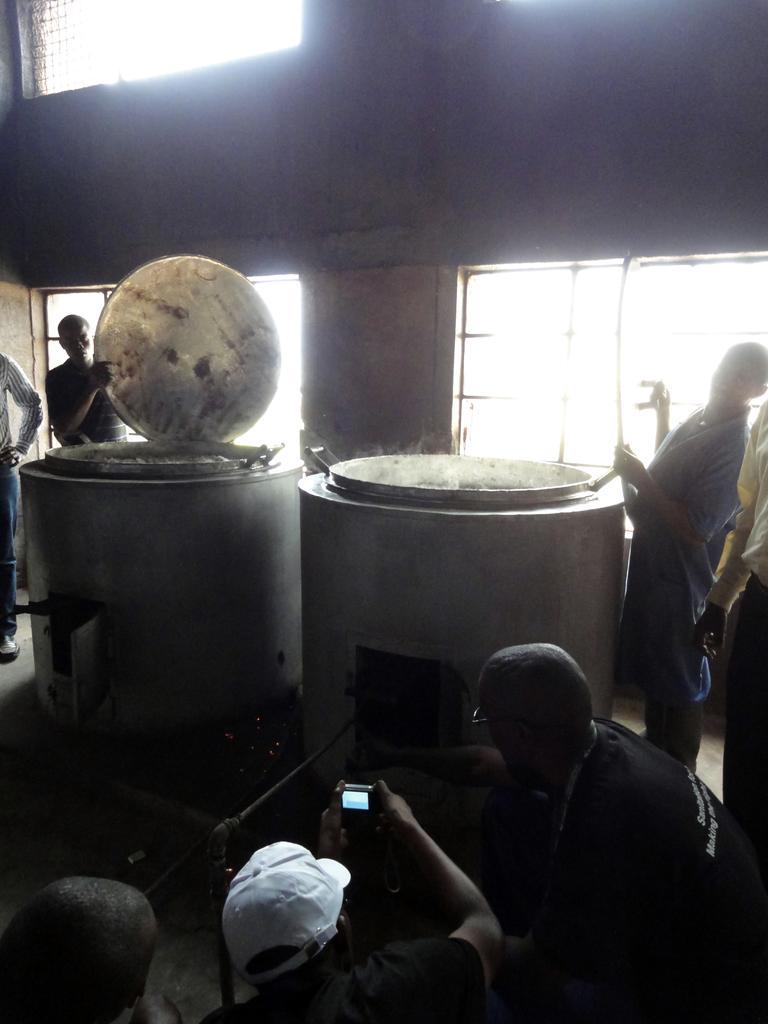Describe this image in one or two sentences. In the foreground there are three persons, one person is taking picture of the tin. In the middle of the image two tins are there and beside every time one person is standing. On the top there is only one ventilator. 